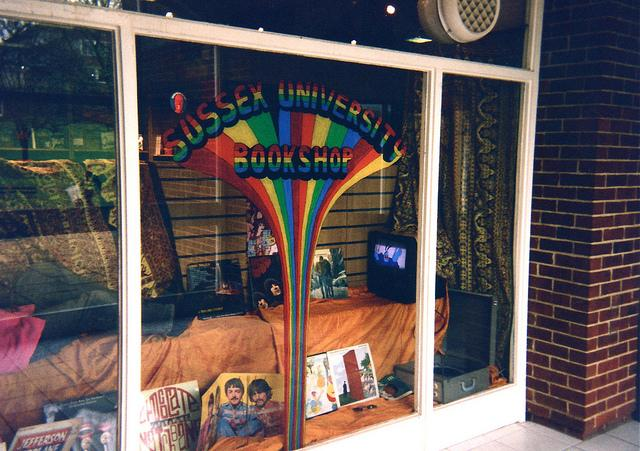What type of clientele does the book store have? Please explain your reasoning. gay. The type is gay. 